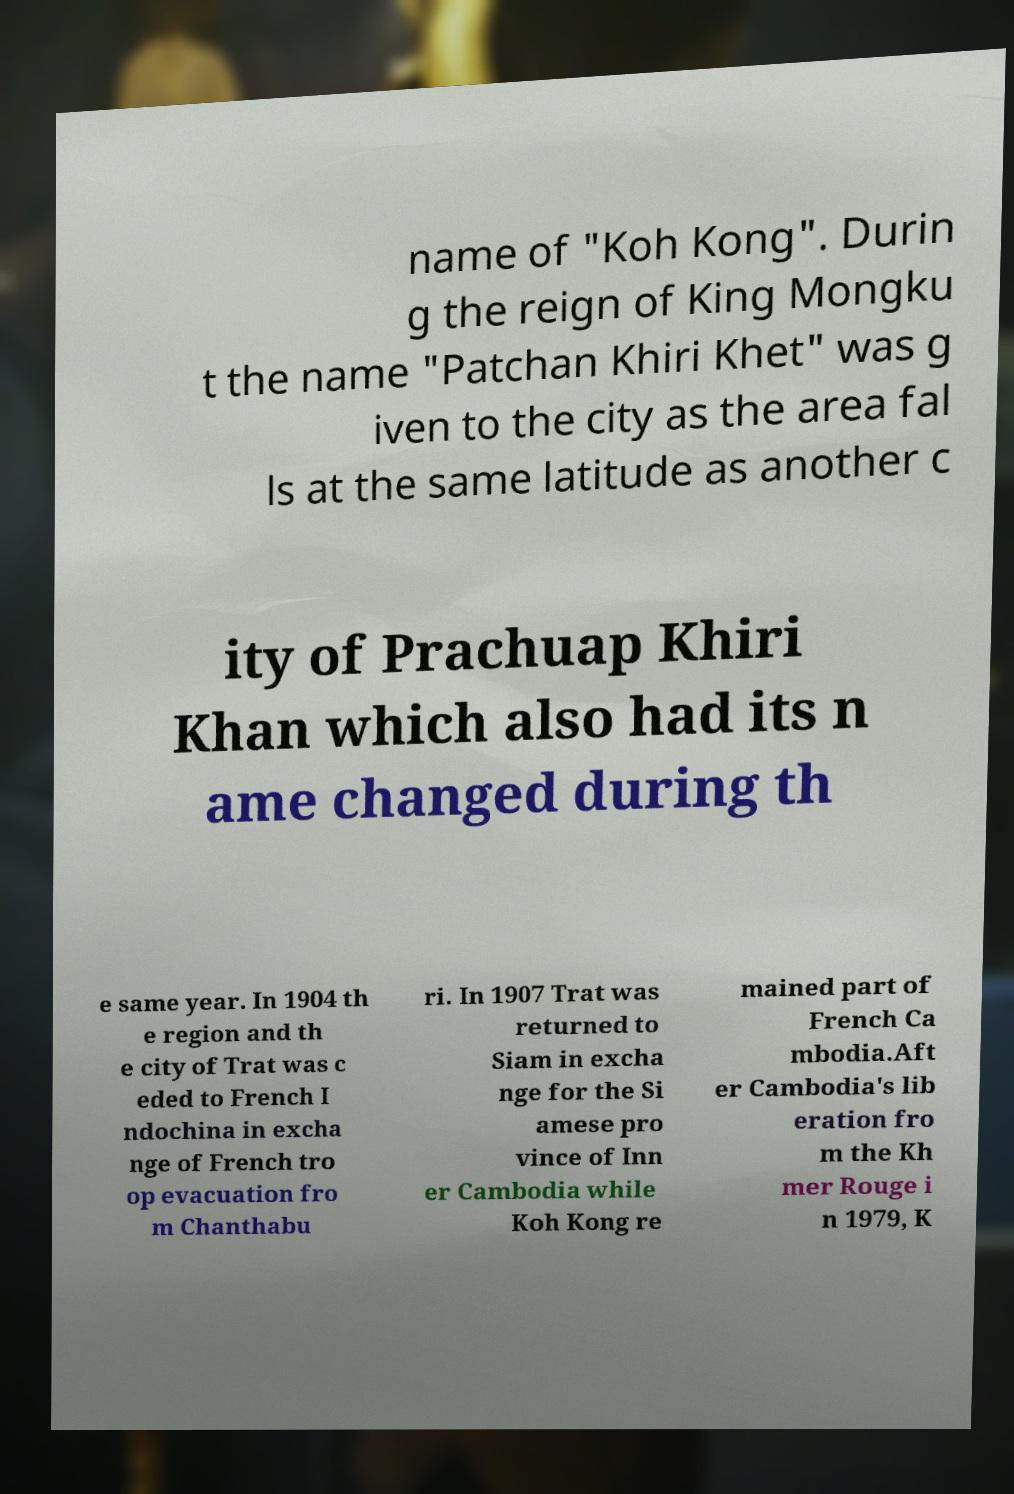Could you assist in decoding the text presented in this image and type it out clearly? name of "Koh Kong". Durin g the reign of King Mongku t the name "Patchan Khiri Khet" was g iven to the city as the area fal ls at the same latitude as another c ity of Prachuap Khiri Khan which also had its n ame changed during th e same year. In 1904 th e region and th e city of Trat was c eded to French I ndochina in excha nge of French tro op evacuation fro m Chanthabu ri. In 1907 Trat was returned to Siam in excha nge for the Si amese pro vince of Inn er Cambodia while Koh Kong re mained part of French Ca mbodia.Aft er Cambodia's lib eration fro m the Kh mer Rouge i n 1979, K 